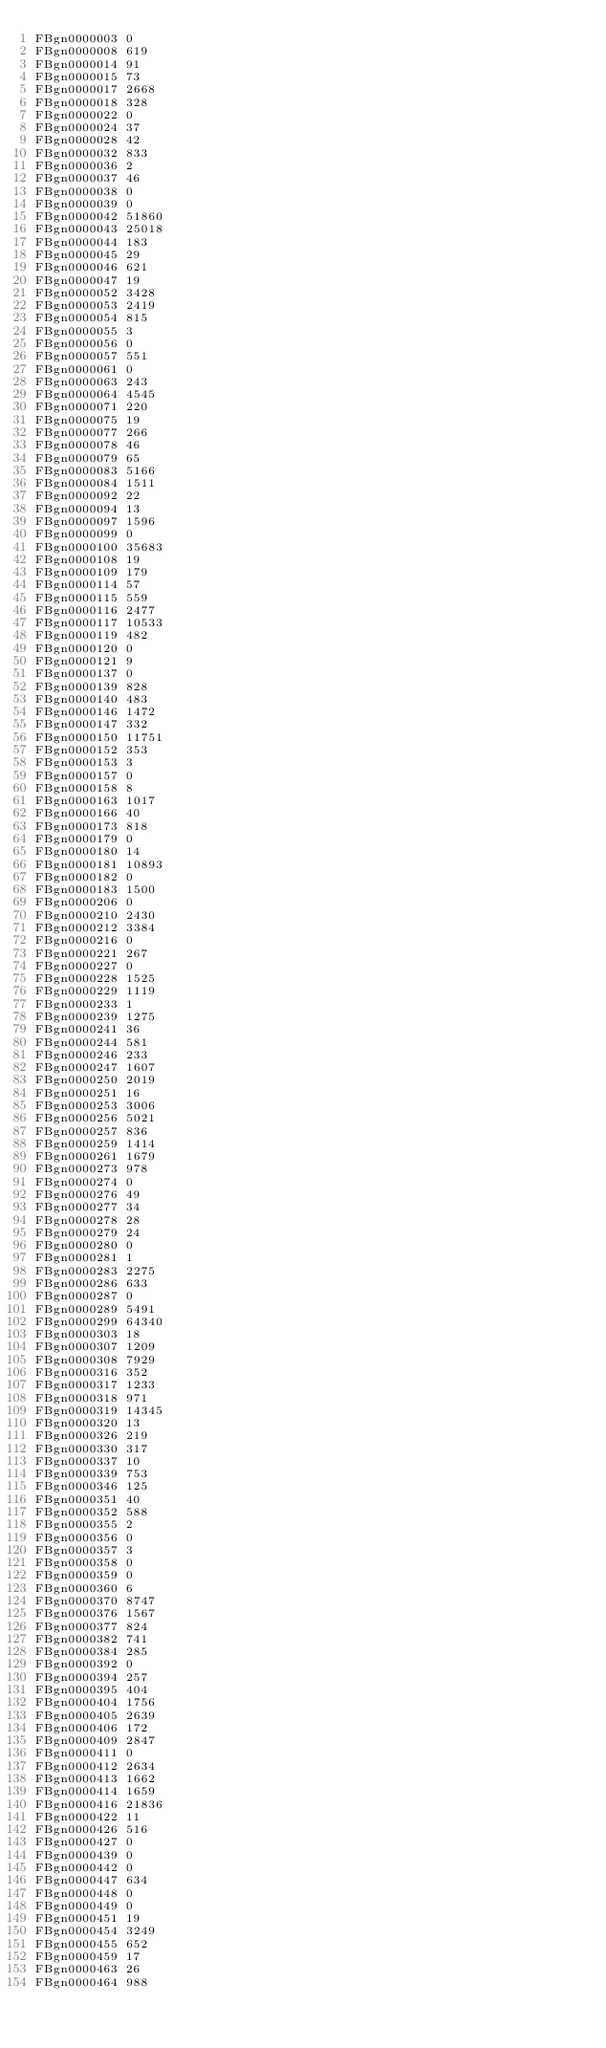<code> <loc_0><loc_0><loc_500><loc_500><_SQL_>FBgn0000003	0
FBgn0000008	619
FBgn0000014	91
FBgn0000015	73
FBgn0000017	2668
FBgn0000018	328
FBgn0000022	0
FBgn0000024	37
FBgn0000028	42
FBgn0000032	833
FBgn0000036	2
FBgn0000037	46
FBgn0000038	0
FBgn0000039	0
FBgn0000042	51860
FBgn0000043	25018
FBgn0000044	183
FBgn0000045	29
FBgn0000046	621
FBgn0000047	19
FBgn0000052	3428
FBgn0000053	2419
FBgn0000054	815
FBgn0000055	3
FBgn0000056	0
FBgn0000057	551
FBgn0000061	0
FBgn0000063	243
FBgn0000064	4545
FBgn0000071	220
FBgn0000075	19
FBgn0000077	266
FBgn0000078	46
FBgn0000079	65
FBgn0000083	5166
FBgn0000084	1511
FBgn0000092	22
FBgn0000094	13
FBgn0000097	1596
FBgn0000099	0
FBgn0000100	35683
FBgn0000108	19
FBgn0000109	179
FBgn0000114	57
FBgn0000115	559
FBgn0000116	2477
FBgn0000117	10533
FBgn0000119	482
FBgn0000120	0
FBgn0000121	9
FBgn0000137	0
FBgn0000139	828
FBgn0000140	483
FBgn0000146	1472
FBgn0000147	332
FBgn0000150	11751
FBgn0000152	353
FBgn0000153	3
FBgn0000157	0
FBgn0000158	8
FBgn0000163	1017
FBgn0000166	40
FBgn0000173	818
FBgn0000179	0
FBgn0000180	14
FBgn0000181	10893
FBgn0000182	0
FBgn0000183	1500
FBgn0000206	0
FBgn0000210	2430
FBgn0000212	3384
FBgn0000216	0
FBgn0000221	267
FBgn0000227	0
FBgn0000228	1525
FBgn0000229	1119
FBgn0000233	1
FBgn0000239	1275
FBgn0000241	36
FBgn0000244	581
FBgn0000246	233
FBgn0000247	1607
FBgn0000250	2019
FBgn0000251	16
FBgn0000253	3006
FBgn0000256	5021
FBgn0000257	836
FBgn0000259	1414
FBgn0000261	1679
FBgn0000273	978
FBgn0000274	0
FBgn0000276	49
FBgn0000277	34
FBgn0000278	28
FBgn0000279	24
FBgn0000280	0
FBgn0000281	1
FBgn0000283	2275
FBgn0000286	633
FBgn0000287	0
FBgn0000289	5491
FBgn0000299	64340
FBgn0000303	18
FBgn0000307	1209
FBgn0000308	7929
FBgn0000316	352
FBgn0000317	1233
FBgn0000318	971
FBgn0000319	14345
FBgn0000320	13
FBgn0000326	219
FBgn0000330	317
FBgn0000337	10
FBgn0000339	753
FBgn0000346	125
FBgn0000351	40
FBgn0000352	588
FBgn0000355	2
FBgn0000356	0
FBgn0000357	3
FBgn0000358	0
FBgn0000359	0
FBgn0000360	6
FBgn0000370	8747
FBgn0000376	1567
FBgn0000377	824
FBgn0000382	741
FBgn0000384	285
FBgn0000392	0
FBgn0000394	257
FBgn0000395	404
FBgn0000404	1756
FBgn0000405	2639
FBgn0000406	172
FBgn0000409	2847
FBgn0000411	0
FBgn0000412	2634
FBgn0000413	1662
FBgn0000414	1659
FBgn0000416	21836
FBgn0000422	11
FBgn0000426	516
FBgn0000427	0
FBgn0000439	0
FBgn0000442	0
FBgn0000447	634
FBgn0000448	0
FBgn0000449	0
FBgn0000451	19
FBgn0000454	3249
FBgn0000455	652
FBgn0000459	17
FBgn0000463	26
FBgn0000464	988</code> 